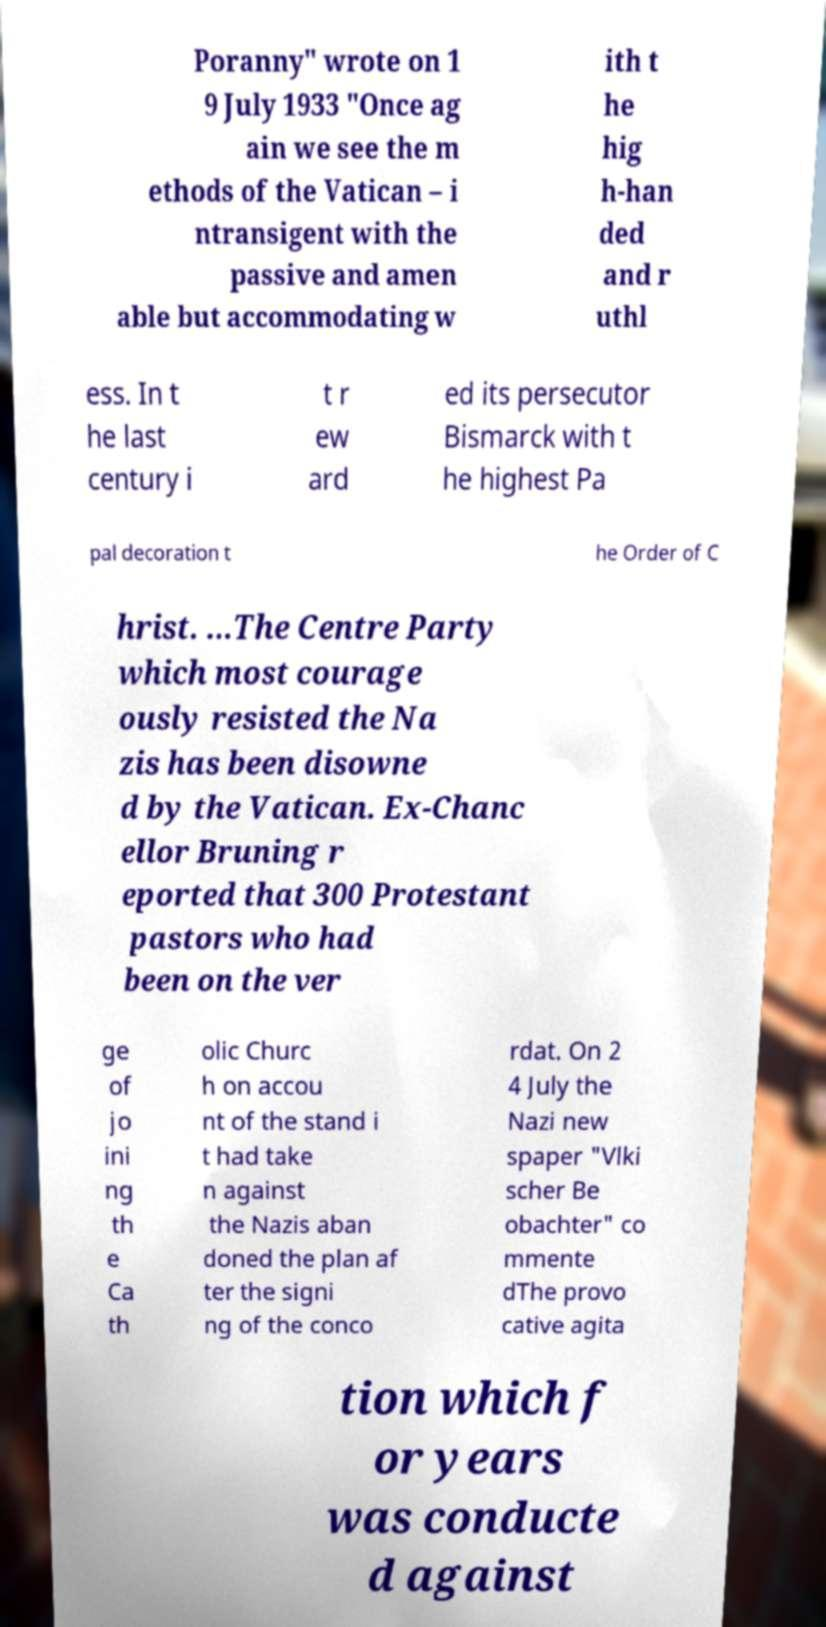I need the written content from this picture converted into text. Can you do that? Poranny" wrote on 1 9 July 1933 "Once ag ain we see the m ethods of the Vatican – i ntransigent with the passive and amen able but accommodating w ith t he hig h-han ded and r uthl ess. In t he last century i t r ew ard ed its persecutor Bismarck with t he highest Pa pal decoration t he Order of C hrist. ...The Centre Party which most courage ously resisted the Na zis has been disowne d by the Vatican. Ex-Chanc ellor Bruning r eported that 300 Protestant pastors who had been on the ver ge of jo ini ng th e Ca th olic Churc h on accou nt of the stand i t had take n against the Nazis aban doned the plan af ter the signi ng of the conco rdat. On 2 4 July the Nazi new spaper "Vlki scher Be obachter" co mmente dThe provo cative agita tion which f or years was conducte d against 